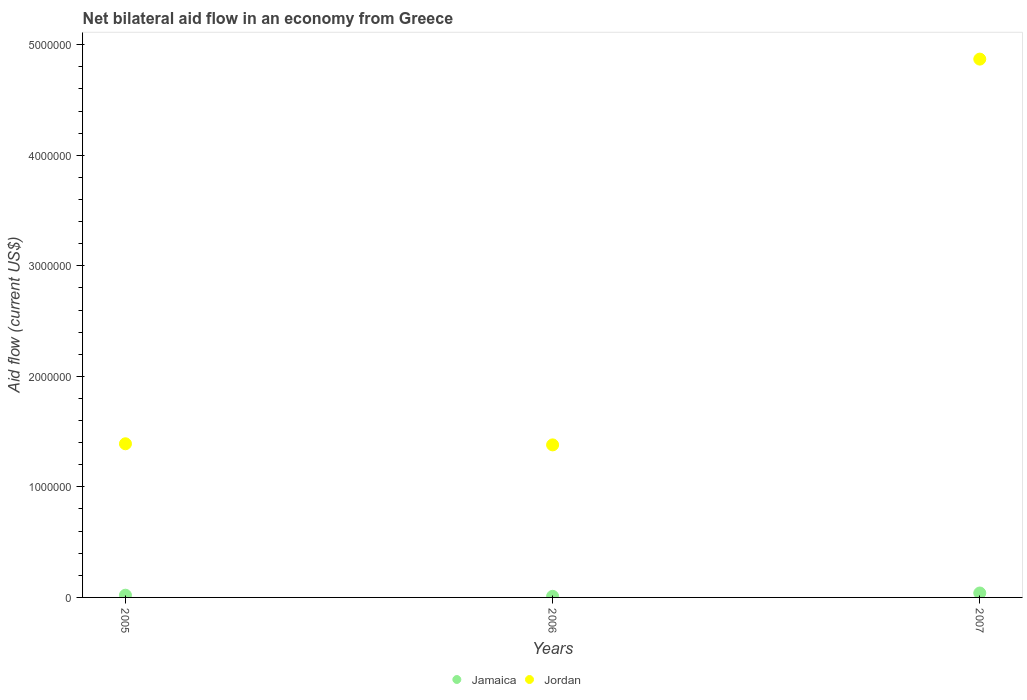How many different coloured dotlines are there?
Ensure brevity in your answer.  2. Is the number of dotlines equal to the number of legend labels?
Provide a short and direct response. Yes. Across all years, what is the maximum net bilateral aid flow in Jordan?
Keep it short and to the point. 4.87e+06. Across all years, what is the minimum net bilateral aid flow in Jordan?
Give a very brief answer. 1.38e+06. What is the total net bilateral aid flow in Jordan in the graph?
Offer a very short reply. 7.64e+06. What is the difference between the net bilateral aid flow in Jordan in 2006 and that in 2007?
Your response must be concise. -3.49e+06. What is the difference between the net bilateral aid flow in Jamaica in 2005 and the net bilateral aid flow in Jordan in 2007?
Offer a very short reply. -4.85e+06. What is the average net bilateral aid flow in Jamaica per year?
Offer a very short reply. 2.33e+04. In the year 2007, what is the difference between the net bilateral aid flow in Jamaica and net bilateral aid flow in Jordan?
Your response must be concise. -4.83e+06. In how many years, is the net bilateral aid flow in Jamaica greater than 4000000 US$?
Make the answer very short. 0. What is the ratio of the net bilateral aid flow in Jordan in 2005 to that in 2006?
Provide a succinct answer. 1.01. Is the difference between the net bilateral aid flow in Jamaica in 2005 and 2006 greater than the difference between the net bilateral aid flow in Jordan in 2005 and 2006?
Keep it short and to the point. No. What is the difference between the highest and the second highest net bilateral aid flow in Jamaica?
Your response must be concise. 2.00e+04. What is the difference between the highest and the lowest net bilateral aid flow in Jamaica?
Provide a short and direct response. 3.00e+04. Does the net bilateral aid flow in Jordan monotonically increase over the years?
Your answer should be very brief. No. Is the net bilateral aid flow in Jamaica strictly greater than the net bilateral aid flow in Jordan over the years?
Give a very brief answer. No. How many dotlines are there?
Offer a terse response. 2. How many years are there in the graph?
Your response must be concise. 3. What is the difference between two consecutive major ticks on the Y-axis?
Your answer should be very brief. 1.00e+06. Are the values on the major ticks of Y-axis written in scientific E-notation?
Make the answer very short. No. How are the legend labels stacked?
Your answer should be very brief. Horizontal. What is the title of the graph?
Provide a succinct answer. Net bilateral aid flow in an economy from Greece. What is the label or title of the X-axis?
Offer a terse response. Years. What is the Aid flow (current US$) in Jordan in 2005?
Offer a very short reply. 1.39e+06. What is the Aid flow (current US$) in Jordan in 2006?
Make the answer very short. 1.38e+06. What is the Aid flow (current US$) in Jamaica in 2007?
Provide a short and direct response. 4.00e+04. What is the Aid flow (current US$) of Jordan in 2007?
Keep it short and to the point. 4.87e+06. Across all years, what is the maximum Aid flow (current US$) in Jordan?
Offer a very short reply. 4.87e+06. Across all years, what is the minimum Aid flow (current US$) of Jordan?
Provide a succinct answer. 1.38e+06. What is the total Aid flow (current US$) of Jamaica in the graph?
Make the answer very short. 7.00e+04. What is the total Aid flow (current US$) of Jordan in the graph?
Make the answer very short. 7.64e+06. What is the difference between the Aid flow (current US$) in Jordan in 2005 and that in 2006?
Provide a succinct answer. 10000. What is the difference between the Aid flow (current US$) of Jamaica in 2005 and that in 2007?
Offer a very short reply. -2.00e+04. What is the difference between the Aid flow (current US$) in Jordan in 2005 and that in 2007?
Offer a terse response. -3.48e+06. What is the difference between the Aid flow (current US$) in Jordan in 2006 and that in 2007?
Ensure brevity in your answer.  -3.49e+06. What is the difference between the Aid flow (current US$) in Jamaica in 2005 and the Aid flow (current US$) in Jordan in 2006?
Your response must be concise. -1.36e+06. What is the difference between the Aid flow (current US$) in Jamaica in 2005 and the Aid flow (current US$) in Jordan in 2007?
Make the answer very short. -4.85e+06. What is the difference between the Aid flow (current US$) of Jamaica in 2006 and the Aid flow (current US$) of Jordan in 2007?
Provide a succinct answer. -4.86e+06. What is the average Aid flow (current US$) of Jamaica per year?
Give a very brief answer. 2.33e+04. What is the average Aid flow (current US$) of Jordan per year?
Provide a short and direct response. 2.55e+06. In the year 2005, what is the difference between the Aid flow (current US$) in Jamaica and Aid flow (current US$) in Jordan?
Give a very brief answer. -1.37e+06. In the year 2006, what is the difference between the Aid flow (current US$) in Jamaica and Aid flow (current US$) in Jordan?
Offer a terse response. -1.37e+06. In the year 2007, what is the difference between the Aid flow (current US$) of Jamaica and Aid flow (current US$) of Jordan?
Provide a succinct answer. -4.83e+06. What is the ratio of the Aid flow (current US$) in Jordan in 2005 to that in 2007?
Give a very brief answer. 0.29. What is the ratio of the Aid flow (current US$) in Jamaica in 2006 to that in 2007?
Provide a short and direct response. 0.25. What is the ratio of the Aid flow (current US$) of Jordan in 2006 to that in 2007?
Offer a very short reply. 0.28. What is the difference between the highest and the second highest Aid flow (current US$) in Jamaica?
Offer a very short reply. 2.00e+04. What is the difference between the highest and the second highest Aid flow (current US$) in Jordan?
Offer a very short reply. 3.48e+06. What is the difference between the highest and the lowest Aid flow (current US$) in Jordan?
Keep it short and to the point. 3.49e+06. 